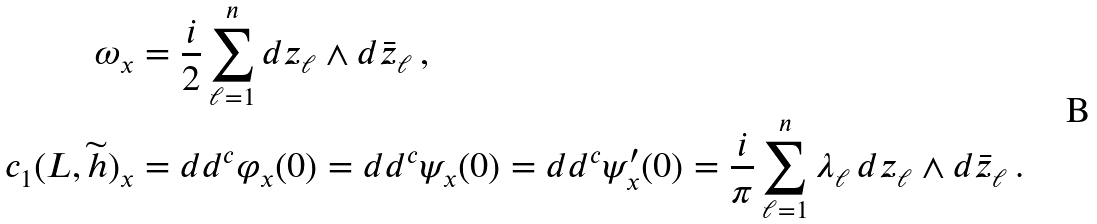<formula> <loc_0><loc_0><loc_500><loc_500>\omega _ { x } & = \frac { i } { 2 } \sum _ { \ell = 1 } ^ { n } d z _ { \ell } \wedge d \bar { z } _ { \ell } \, , \\ c _ { 1 } ( L , \widetilde { h } ) _ { x } & = d d ^ { c } \varphi _ { x } ( 0 ) = d d ^ { c } \psi _ { x } ( 0 ) = d d ^ { c } \psi ^ { \prime } _ { x } ( 0 ) = \frac { i } { \pi } \sum _ { \ell = 1 } ^ { n } \lambda _ { \ell } \, d z _ { \ell } \wedge d \bar { z } _ { \ell } \, .</formula> 